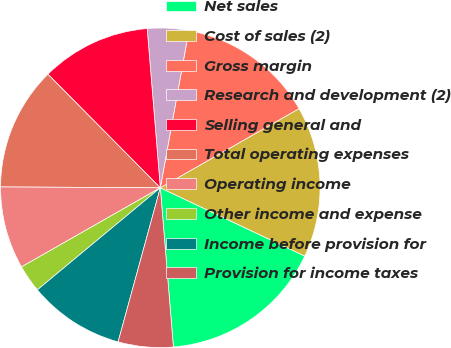<chart> <loc_0><loc_0><loc_500><loc_500><pie_chart><fcel>Net sales<fcel>Cost of sales (2)<fcel>Gross margin<fcel>Research and development (2)<fcel>Selling general and<fcel>Total operating expenses<fcel>Operating income<fcel>Other income and expense<fcel>Income before provision for<fcel>Provision for income taxes<nl><fcel>16.67%<fcel>15.28%<fcel>13.89%<fcel>4.17%<fcel>11.11%<fcel>12.5%<fcel>8.33%<fcel>2.78%<fcel>9.72%<fcel>5.56%<nl></chart> 